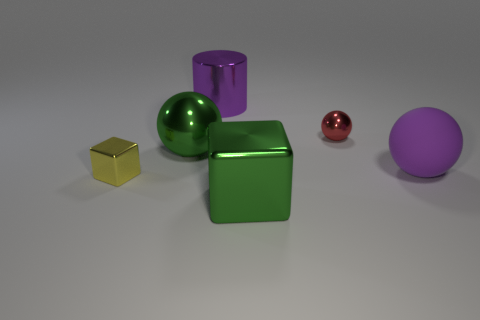Is the number of purple rubber balls that are behind the tiny metal cube greater than the number of tiny matte balls?
Provide a succinct answer. Yes. Are there any other things that have the same material as the purple ball?
Offer a terse response. No. There is a sphere to the left of the shiny cylinder; is it the same color as the large thing in front of the large matte object?
Provide a short and direct response. Yes. What material is the object to the left of the green thing behind the tiny thing in front of the purple matte thing made of?
Your answer should be very brief. Metal. Are there more green objects than blue shiny spheres?
Offer a very short reply. Yes. Is there anything else that has the same color as the big shiny block?
Provide a short and direct response. Yes. What size is the cylinder that is made of the same material as the small block?
Offer a very short reply. Large. What is the yellow thing made of?
Provide a succinct answer. Metal. How many other rubber spheres have the same size as the green sphere?
Your answer should be very brief. 1. There is a large object that is the same color as the big cube; what shape is it?
Give a very brief answer. Sphere. 